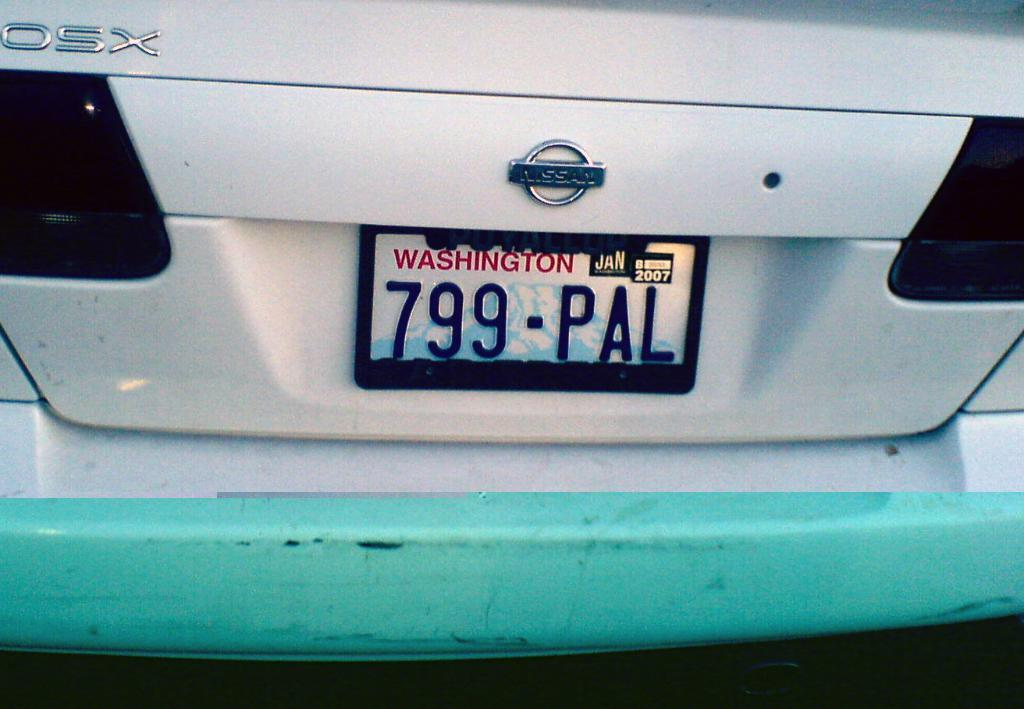<image>
Summarize the visual content of the image. a 799 number that is on the license plate 